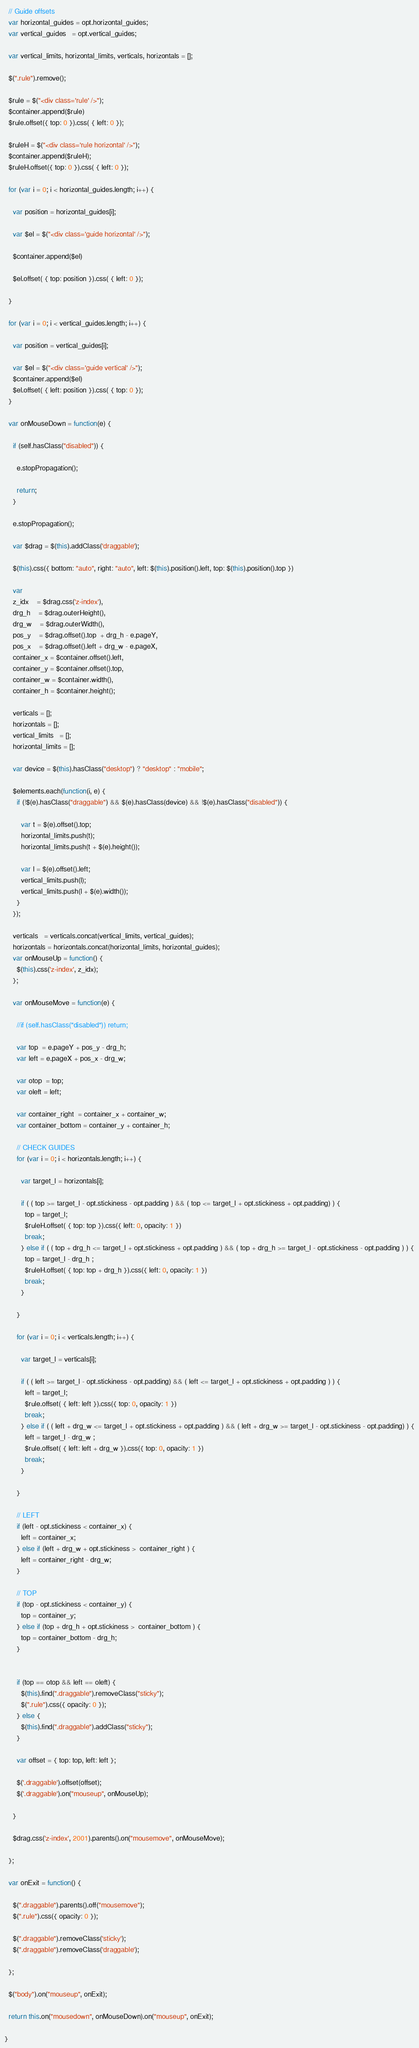<code> <loc_0><loc_0><loc_500><loc_500><_JavaScript_>
  // Guide offsets
  var horizontal_guides = opt.horizontal_guides;
  var vertical_guides   = opt.vertical_guides;

  var vertical_limits, horizontal_limits, verticals, horizontals = []; 

  $(".rule").remove();

  $rule = $("<div class='rule' />");
  $container.append($rule)
  $rule.offset({ top: 0 }).css( { left: 0 });

  $ruleH = $("<div class='rule horizontal' />");
  $container.append($ruleH);
  $ruleH.offset({ top: 0 }).css( { left: 0 });

  for (var i = 0; i < horizontal_guides.length; i++) {

    var position = horizontal_guides[i];

    var $el = $("<div class='guide horizontal' />");

    $container.append($el)

    $el.offset( { top: position }).css( { left: 0 });

  }

  for (var i = 0; i < vertical_guides.length; i++) {

    var position = vertical_guides[i];

    var $el = $("<div class='guide vertical' />");
    $container.append($el)
    $el.offset( { left: position }).css( { top: 0 });
  }

  var onMouseDown = function(e) {

    if (self.hasClass("disabled")) {

      e.stopPropagation();

      return;
    }

    e.stopPropagation();

    var $drag = $(this).addClass('draggable');

    $(this).css({ bottom: "auto", right: "auto", left: $(this).position().left, top: $(this).position().top })

    var
    z_idx    = $drag.css('z-index'),
    drg_h    = $drag.outerHeight(),
    drg_w    = $drag.outerWidth(),
    pos_y    = $drag.offset().top  + drg_h - e.pageY,
    pos_x    = $drag.offset().left + drg_w - e.pageX,
    container_x = $container.offset().left,
    container_y = $container.offset().top,
    container_w = $container.width(),
    container_h = $container.height();

    verticals = [];
    horizontals = [];
    vertical_limits   = [];
    horizontal_limits = [];

    var device = $(this).hasClass("desktop") ? "desktop" : "mobile";

    $elements.each(function(i, e) {
      if (!$(e).hasClass("draggable") && $(e).hasClass(device) && !$(e).hasClass("disabled")) {

        var t = $(e).offset().top;
        horizontal_limits.push(t);
        horizontal_limits.push(t + $(e).height());

        var l = $(e).offset().left;
        vertical_limits.push(l);
        vertical_limits.push(l + $(e).width());
      }
    });

    verticals   = verticals.concat(vertical_limits, vertical_guides);
    horizontals = horizontals.concat(horizontal_limits, horizontal_guides);
    var onMouseUp = function() {
      $(this).css('z-index', z_idx);
    };

    var onMouseMove = function(e) {

      //if (self.hasClass("disabled")) return;

      var top  = e.pageY + pos_y - drg_h;
      var left = e.pageX + pos_x - drg_w;

      var otop  = top; 
      var oleft = left;

      var container_right  = container_x + container_w;
      var container_bottom = container_y + container_h;

      // CHECK GUIDES
      for (var i = 0; i < horizontals.length; i++) {

        var target_l = horizontals[i];

        if ( ( top >= target_l - opt.stickiness - opt.padding ) && ( top <= target_l + opt.stickiness + opt.padding) ) {
          top = target_l;
          $ruleH.offset( { top: top }).css({ left: 0, opacity: 1 })
          break;
        } else if ( ( top + drg_h <= target_l + opt.stickiness + opt.padding ) && ( top + drg_h >= target_l - opt.stickiness - opt.padding ) ) {
          top = target_l - drg_h ;
          $ruleH.offset( { top: top + drg_h }).css({ left: 0, opacity: 1 })
          break;
        }

      }

      for (var i = 0; i < verticals.length; i++) {

        var target_l = verticals[i];

        if ( ( left >= target_l - opt.stickiness - opt.padding) && ( left <= target_l + opt.stickiness + opt.padding ) ) {
          left = target_l;
          $rule.offset( { left: left }).css({ top: 0, opacity: 1 })
          break;
        } else if ( ( left + drg_w <= target_l + opt.stickiness + opt.padding ) && ( left + drg_w >= target_l - opt.stickiness - opt.padding) ) {
          left = target_l - drg_w ;
          $rule.offset( { left: left + drg_w }).css({ top: 0, opacity: 1 })
          break;
        } 

      }

      // LEFT
      if (left - opt.stickiness < container_x) {
        left = container_x;
      } else if (left + drg_w + opt.stickiness >  container_right ) {
        left = container_right - drg_w;
      }

      // TOP
      if (top - opt.stickiness < container_y) {
        top = container_y;
      } else if (top + drg_h + opt.stickiness >  container_bottom ) {
        top = container_bottom - drg_h;
      } 


      if (top == otop && left == oleft) {
        $(this).find(".draggable").removeClass("sticky");
        $(".rule").css({ opacity: 0 });
      } else {
        $(this).find(".draggable").addClass("sticky");
      }

      var offset = { top: top, left: left };

      $('.draggable').offset(offset);
      $('.draggable').on("mouseup", onMouseUp);

    }

    $drag.css('z-index', 2001).parents().on("mousemove", onMouseMove);

  };

  var onExit = function() {

    $(".draggable").parents().off("mousemove");
    $(".rule").css({ opacity: 0 });

    $(".draggable").removeClass('sticky');
    $(".draggable").removeClass('draggable');

  };

  $("body").on("mouseup", onExit);

  return this.on("mousedown", onMouseDown).on("mouseup", onExit);

}
</code> 